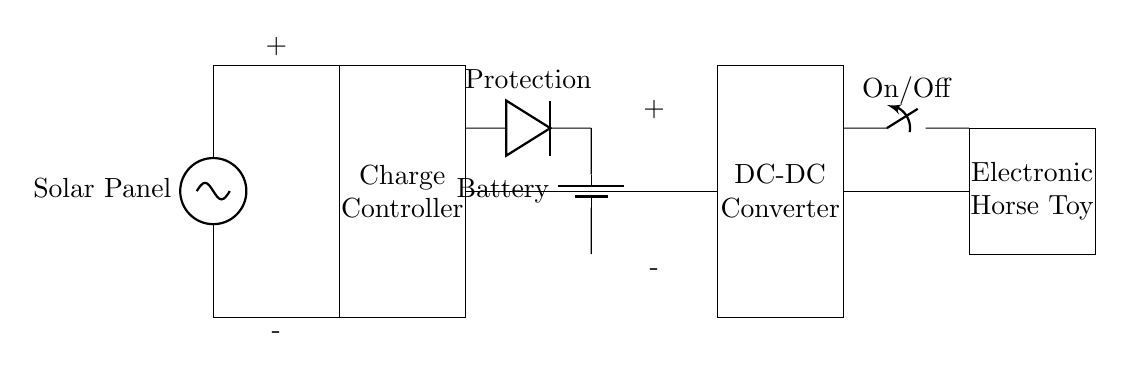What is the first component in the circuit? The first component is the Solar Panel, which is represented at the top of the diagram. It captures sunlight to provide energy.
Answer: Solar Panel What does the rectangle labeled "Charge Controller" do? The Charge Controller regulates the voltage and current coming from the solar panel to ensure the battery is charged correctly without damage.
Answer: Regulates charging What type of component is shown on the right between the battery and the toy? The component is a DC-DC Converter, which adjusts the voltage output to the required level for the electronic horse toy.
Answer: DC-DC Converter How many main components are involved in this charging system? The main components in the charging system consist of five: Solar Panel, Charge Controller, Battery, DC-DC Converter, and Electronic Horse Toy.
Answer: Five What does the diode in the circuit provide? The diode provides protection against reverse polarity, ensuring that the current flows only in one direction, protecting the battery and other components.
Answer: Protection What is the purpose of the On/Off switch in the circuit? The On/Off switch allows the user to control the power supplied to the electronic horse toy, enabling or disabling its operation as needed.
Answer: Control power 